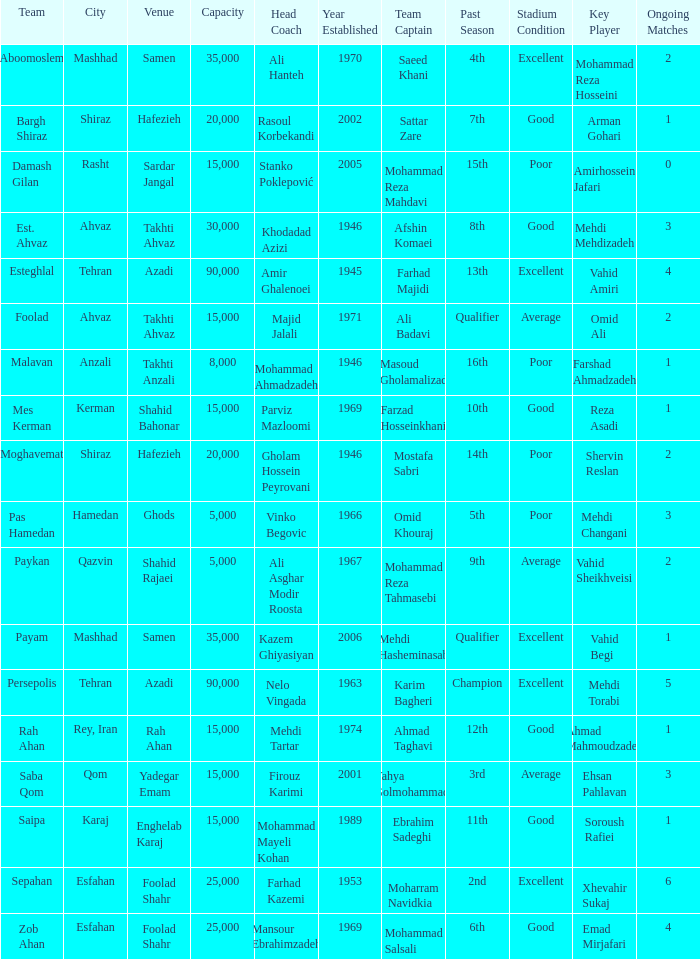Can you parse all the data within this table? {'header': ['Team', 'City', 'Venue', 'Capacity', 'Head Coach', 'Year Established', 'Team Captain', 'Past Season', 'Stadium Condition', 'Key Player', 'Ongoing Matches'], 'rows': [['Aboomoslem', 'Mashhad', 'Samen', '35,000', 'Ali Hanteh', '1970', 'Saeed Khani', '4th', 'Excellent', 'Mohammad Reza Hosseini', '2'], ['Bargh Shiraz', 'Shiraz', 'Hafezieh', '20,000', 'Rasoul Korbekandi', '2002', 'Sattar Zare', '7th', 'Good', 'Arman Gohari', '1'], ['Damash Gilan', 'Rasht', 'Sardar Jangal', '15,000', 'Stanko Poklepović', '2005', 'Mohammad Reza Mahdavi', '15th', 'Poor', 'Amirhossein Jafari', '0'], ['Est. Ahvaz', 'Ahvaz', 'Takhti Ahvaz', '30,000', 'Khodadad Azizi', '1946', 'Afshin Komaei', '8th', 'Good', 'Mehdi Mehdizadeh', '3'], ['Esteghlal', 'Tehran', 'Azadi', '90,000', 'Amir Ghalenoei', '1945', 'Farhad Majidi', '13th', 'Excellent', 'Vahid Amiri', '4'], ['Foolad', 'Ahvaz', 'Takhti Ahvaz', '15,000', 'Majid Jalali', '1971', 'Ali Badavi', 'Qualifier', 'Average', 'Omid Ali', '2'], ['Malavan', 'Anzali', 'Takhti Anzali', '8,000', 'Mohammad Ahmadzadeh', '1946', 'Masoud Gholamalizad', '16th', 'Poor', 'Farshad Ahmadzadeh', '1'], ['Mes Kerman', 'Kerman', 'Shahid Bahonar', '15,000', 'Parviz Mazloomi', '1969', 'Farzad Hosseinkhani', '10th', 'Good', 'Reza Asadi', '1'], ['Moghavemat', 'Shiraz', 'Hafezieh', '20,000', 'Gholam Hossein Peyrovani', '1946', 'Mostafa Sabri', '14th', 'Poor', 'Shervin Reslan', '2'], ['Pas Hamedan', 'Hamedan', 'Ghods', '5,000', 'Vinko Begovic', '1966', 'Omid Khouraj', '5th', 'Poor', 'Mehdi Changani', '3'], ['Paykan', 'Qazvin', 'Shahid Rajaei', '5,000', 'Ali Asghar Modir Roosta', '1967', 'Mohammad Reza Tahmasebi', '9th', 'Average', 'Vahid Sheikhveisi', '2'], ['Payam', 'Mashhad', 'Samen', '35,000', 'Kazem Ghiyasiyan', '2006', 'Mehdi Hasheminasab', 'Qualifier', 'Excellent', 'Vahid Begi', '1'], ['Persepolis', 'Tehran', 'Azadi', '90,000', 'Nelo Vingada', '1963', 'Karim Bagheri', 'Champion', 'Excellent', 'Mehdi Torabi', '5'], ['Rah Ahan', 'Rey, Iran', 'Rah Ahan', '15,000', 'Mehdi Tartar', '1974', 'Ahmad Taghavi', '12th', 'Good', 'Ahmad Mahmoudzadeh', '1'], ['Saba Qom', 'Qom', 'Yadegar Emam', '15,000', 'Firouz Karimi', '2001', 'Yahya Golmohammadi', '3rd', 'Average', 'Ehsan Pahlavan', '3'], ['Saipa', 'Karaj', 'Enghelab Karaj', '15,000', 'Mohammad Mayeli Kohan', '1989', 'Ebrahim Sadeghi', '11th', 'Good', 'Soroush Rafiei', '1'], ['Sepahan', 'Esfahan', 'Foolad Shahr', '25,000', 'Farhad Kazemi', '1953', 'Moharram Navidkia', '2nd', 'Excellent', 'Xhevahir Sukaj', '6'], ['Zob Ahan', 'Esfahan', 'Foolad Shahr', '25,000', 'Mansour Ebrahimzadeh', '1969', 'Mohammad Salsali', '6th', 'Good', 'Emad Mirjafari', '4']]} What is the Capacity of the Venue of Head Coach Farhad Kazemi? 25000.0. 